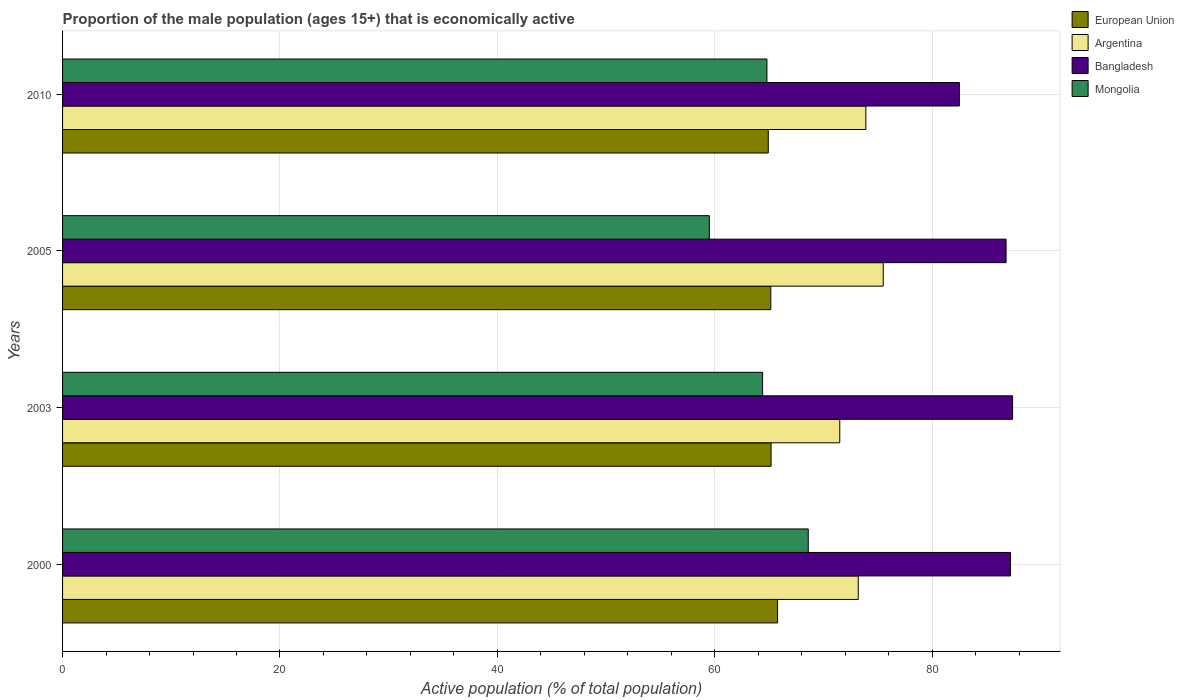How many different coloured bars are there?
Your answer should be very brief. 4. Are the number of bars per tick equal to the number of legend labels?
Provide a succinct answer. Yes. What is the proportion of the male population that is economically active in European Union in 2003?
Make the answer very short. 65.18. Across all years, what is the maximum proportion of the male population that is economically active in Bangladesh?
Provide a short and direct response. 87.4. Across all years, what is the minimum proportion of the male population that is economically active in Bangladesh?
Offer a terse response. 82.5. In which year was the proportion of the male population that is economically active in European Union maximum?
Ensure brevity in your answer.  2000. In which year was the proportion of the male population that is economically active in Mongolia minimum?
Give a very brief answer. 2005. What is the total proportion of the male population that is economically active in Bangladesh in the graph?
Ensure brevity in your answer.  343.9. What is the difference between the proportion of the male population that is economically active in Bangladesh in 2000 and that in 2010?
Offer a terse response. 4.7. What is the difference between the proportion of the male population that is economically active in Mongolia in 2010 and the proportion of the male population that is economically active in European Union in 2003?
Keep it short and to the point. -0.38. What is the average proportion of the male population that is economically active in Bangladesh per year?
Keep it short and to the point. 85.98. In the year 2000, what is the difference between the proportion of the male population that is economically active in European Union and proportion of the male population that is economically active in Argentina?
Ensure brevity in your answer.  -7.42. What is the ratio of the proportion of the male population that is economically active in Mongolia in 2003 to that in 2005?
Give a very brief answer. 1.08. Is the proportion of the male population that is economically active in Argentina in 2000 less than that in 2010?
Your response must be concise. Yes. Is the difference between the proportion of the male population that is economically active in European Union in 2000 and 2005 greater than the difference between the proportion of the male population that is economically active in Argentina in 2000 and 2005?
Keep it short and to the point. Yes. What is the difference between the highest and the second highest proportion of the male population that is economically active in Bangladesh?
Your answer should be very brief. 0.2. What is the difference between the highest and the lowest proportion of the male population that is economically active in Bangladesh?
Keep it short and to the point. 4.9. Is it the case that in every year, the sum of the proportion of the male population that is economically active in Mongolia and proportion of the male population that is economically active in Bangladesh is greater than the sum of proportion of the male population that is economically active in Argentina and proportion of the male population that is economically active in European Union?
Provide a succinct answer. No. What does the 3rd bar from the top in 2005 represents?
Provide a short and direct response. Argentina. What does the 3rd bar from the bottom in 2010 represents?
Offer a very short reply. Bangladesh. What is the difference between two consecutive major ticks on the X-axis?
Keep it short and to the point. 20. Are the values on the major ticks of X-axis written in scientific E-notation?
Your answer should be very brief. No. Does the graph contain any zero values?
Keep it short and to the point. No. How many legend labels are there?
Provide a short and direct response. 4. What is the title of the graph?
Offer a terse response. Proportion of the male population (ages 15+) that is economically active. Does "Cayman Islands" appear as one of the legend labels in the graph?
Give a very brief answer. No. What is the label or title of the X-axis?
Ensure brevity in your answer.  Active population (% of total population). What is the Active population (% of total population) of European Union in 2000?
Provide a succinct answer. 65.78. What is the Active population (% of total population) in Argentina in 2000?
Your response must be concise. 73.2. What is the Active population (% of total population) of Bangladesh in 2000?
Your answer should be compact. 87.2. What is the Active population (% of total population) in Mongolia in 2000?
Your answer should be very brief. 68.6. What is the Active population (% of total population) of European Union in 2003?
Provide a succinct answer. 65.18. What is the Active population (% of total population) of Argentina in 2003?
Give a very brief answer. 71.5. What is the Active population (% of total population) of Bangladesh in 2003?
Provide a short and direct response. 87.4. What is the Active population (% of total population) of Mongolia in 2003?
Keep it short and to the point. 64.4. What is the Active population (% of total population) of European Union in 2005?
Give a very brief answer. 65.15. What is the Active population (% of total population) of Argentina in 2005?
Your response must be concise. 75.5. What is the Active population (% of total population) in Bangladesh in 2005?
Give a very brief answer. 86.8. What is the Active population (% of total population) in Mongolia in 2005?
Offer a terse response. 59.5. What is the Active population (% of total population) in European Union in 2010?
Make the answer very short. 64.92. What is the Active population (% of total population) of Argentina in 2010?
Provide a short and direct response. 73.9. What is the Active population (% of total population) of Bangladesh in 2010?
Provide a short and direct response. 82.5. What is the Active population (% of total population) of Mongolia in 2010?
Give a very brief answer. 64.8. Across all years, what is the maximum Active population (% of total population) of European Union?
Your response must be concise. 65.78. Across all years, what is the maximum Active population (% of total population) of Argentina?
Provide a short and direct response. 75.5. Across all years, what is the maximum Active population (% of total population) in Bangladesh?
Your answer should be very brief. 87.4. Across all years, what is the maximum Active population (% of total population) of Mongolia?
Provide a short and direct response. 68.6. Across all years, what is the minimum Active population (% of total population) of European Union?
Your response must be concise. 64.92. Across all years, what is the minimum Active population (% of total population) of Argentina?
Keep it short and to the point. 71.5. Across all years, what is the minimum Active population (% of total population) in Bangladesh?
Give a very brief answer. 82.5. Across all years, what is the minimum Active population (% of total population) of Mongolia?
Offer a very short reply. 59.5. What is the total Active population (% of total population) in European Union in the graph?
Your answer should be very brief. 261.03. What is the total Active population (% of total population) in Argentina in the graph?
Your response must be concise. 294.1. What is the total Active population (% of total population) in Bangladesh in the graph?
Your answer should be very brief. 343.9. What is the total Active population (% of total population) in Mongolia in the graph?
Make the answer very short. 257.3. What is the difference between the Active population (% of total population) of European Union in 2000 and that in 2003?
Provide a short and direct response. 0.6. What is the difference between the Active population (% of total population) in European Union in 2000 and that in 2005?
Offer a very short reply. 0.62. What is the difference between the Active population (% of total population) of Argentina in 2000 and that in 2005?
Your answer should be very brief. -2.3. What is the difference between the Active population (% of total population) in Mongolia in 2000 and that in 2005?
Your answer should be compact. 9.1. What is the difference between the Active population (% of total population) in European Union in 2000 and that in 2010?
Provide a short and direct response. 0.86. What is the difference between the Active population (% of total population) of Bangladesh in 2000 and that in 2010?
Provide a short and direct response. 4.7. What is the difference between the Active population (% of total population) of Mongolia in 2000 and that in 2010?
Ensure brevity in your answer.  3.8. What is the difference between the Active population (% of total population) in European Union in 2003 and that in 2005?
Your answer should be compact. 0.03. What is the difference between the Active population (% of total population) in Bangladesh in 2003 and that in 2005?
Your answer should be very brief. 0.6. What is the difference between the Active population (% of total population) of Mongolia in 2003 and that in 2005?
Make the answer very short. 4.9. What is the difference between the Active population (% of total population) of European Union in 2003 and that in 2010?
Give a very brief answer. 0.26. What is the difference between the Active population (% of total population) in Mongolia in 2003 and that in 2010?
Your answer should be very brief. -0.4. What is the difference between the Active population (% of total population) of European Union in 2005 and that in 2010?
Give a very brief answer. 0.23. What is the difference between the Active population (% of total population) of Bangladesh in 2005 and that in 2010?
Make the answer very short. 4.3. What is the difference between the Active population (% of total population) in European Union in 2000 and the Active population (% of total population) in Argentina in 2003?
Your answer should be very brief. -5.72. What is the difference between the Active population (% of total population) in European Union in 2000 and the Active population (% of total population) in Bangladesh in 2003?
Your answer should be compact. -21.62. What is the difference between the Active population (% of total population) in European Union in 2000 and the Active population (% of total population) in Mongolia in 2003?
Keep it short and to the point. 1.38. What is the difference between the Active population (% of total population) in Argentina in 2000 and the Active population (% of total population) in Bangladesh in 2003?
Your answer should be compact. -14.2. What is the difference between the Active population (% of total population) in Bangladesh in 2000 and the Active population (% of total population) in Mongolia in 2003?
Offer a very short reply. 22.8. What is the difference between the Active population (% of total population) in European Union in 2000 and the Active population (% of total population) in Argentina in 2005?
Your answer should be compact. -9.72. What is the difference between the Active population (% of total population) of European Union in 2000 and the Active population (% of total population) of Bangladesh in 2005?
Make the answer very short. -21.02. What is the difference between the Active population (% of total population) in European Union in 2000 and the Active population (% of total population) in Mongolia in 2005?
Provide a short and direct response. 6.28. What is the difference between the Active population (% of total population) in Argentina in 2000 and the Active population (% of total population) in Mongolia in 2005?
Keep it short and to the point. 13.7. What is the difference between the Active population (% of total population) of Bangladesh in 2000 and the Active population (% of total population) of Mongolia in 2005?
Keep it short and to the point. 27.7. What is the difference between the Active population (% of total population) in European Union in 2000 and the Active population (% of total population) in Argentina in 2010?
Ensure brevity in your answer.  -8.12. What is the difference between the Active population (% of total population) in European Union in 2000 and the Active population (% of total population) in Bangladesh in 2010?
Ensure brevity in your answer.  -16.72. What is the difference between the Active population (% of total population) of European Union in 2000 and the Active population (% of total population) of Mongolia in 2010?
Provide a succinct answer. 0.98. What is the difference between the Active population (% of total population) in Argentina in 2000 and the Active population (% of total population) in Bangladesh in 2010?
Offer a very short reply. -9.3. What is the difference between the Active population (% of total population) of Argentina in 2000 and the Active population (% of total population) of Mongolia in 2010?
Your answer should be compact. 8.4. What is the difference between the Active population (% of total population) in Bangladesh in 2000 and the Active population (% of total population) in Mongolia in 2010?
Your response must be concise. 22.4. What is the difference between the Active population (% of total population) of European Union in 2003 and the Active population (% of total population) of Argentina in 2005?
Your answer should be very brief. -10.32. What is the difference between the Active population (% of total population) of European Union in 2003 and the Active population (% of total population) of Bangladesh in 2005?
Give a very brief answer. -21.62. What is the difference between the Active population (% of total population) in European Union in 2003 and the Active population (% of total population) in Mongolia in 2005?
Your answer should be compact. 5.68. What is the difference between the Active population (% of total population) of Argentina in 2003 and the Active population (% of total population) of Bangladesh in 2005?
Provide a succinct answer. -15.3. What is the difference between the Active population (% of total population) of Bangladesh in 2003 and the Active population (% of total population) of Mongolia in 2005?
Keep it short and to the point. 27.9. What is the difference between the Active population (% of total population) of European Union in 2003 and the Active population (% of total population) of Argentina in 2010?
Your response must be concise. -8.72. What is the difference between the Active population (% of total population) in European Union in 2003 and the Active population (% of total population) in Bangladesh in 2010?
Your answer should be very brief. -17.32. What is the difference between the Active population (% of total population) in European Union in 2003 and the Active population (% of total population) in Mongolia in 2010?
Offer a very short reply. 0.38. What is the difference between the Active population (% of total population) of Argentina in 2003 and the Active population (% of total population) of Mongolia in 2010?
Your answer should be compact. 6.7. What is the difference between the Active population (% of total population) in Bangladesh in 2003 and the Active population (% of total population) in Mongolia in 2010?
Your answer should be very brief. 22.6. What is the difference between the Active population (% of total population) of European Union in 2005 and the Active population (% of total population) of Argentina in 2010?
Ensure brevity in your answer.  -8.75. What is the difference between the Active population (% of total population) of European Union in 2005 and the Active population (% of total population) of Bangladesh in 2010?
Ensure brevity in your answer.  -17.35. What is the difference between the Active population (% of total population) in European Union in 2005 and the Active population (% of total population) in Mongolia in 2010?
Provide a succinct answer. 0.35. What is the difference between the Active population (% of total population) of Argentina in 2005 and the Active population (% of total population) of Mongolia in 2010?
Keep it short and to the point. 10.7. What is the difference between the Active population (% of total population) of Bangladesh in 2005 and the Active population (% of total population) of Mongolia in 2010?
Ensure brevity in your answer.  22. What is the average Active population (% of total population) of European Union per year?
Make the answer very short. 65.26. What is the average Active population (% of total population) of Argentina per year?
Keep it short and to the point. 73.53. What is the average Active population (% of total population) in Bangladesh per year?
Provide a short and direct response. 85.97. What is the average Active population (% of total population) of Mongolia per year?
Your answer should be compact. 64.33. In the year 2000, what is the difference between the Active population (% of total population) of European Union and Active population (% of total population) of Argentina?
Provide a short and direct response. -7.42. In the year 2000, what is the difference between the Active population (% of total population) in European Union and Active population (% of total population) in Bangladesh?
Offer a terse response. -21.42. In the year 2000, what is the difference between the Active population (% of total population) in European Union and Active population (% of total population) in Mongolia?
Your response must be concise. -2.82. In the year 2000, what is the difference between the Active population (% of total population) of Argentina and Active population (% of total population) of Mongolia?
Give a very brief answer. 4.6. In the year 2003, what is the difference between the Active population (% of total population) of European Union and Active population (% of total population) of Argentina?
Offer a very short reply. -6.32. In the year 2003, what is the difference between the Active population (% of total population) of European Union and Active population (% of total population) of Bangladesh?
Your answer should be very brief. -22.22. In the year 2003, what is the difference between the Active population (% of total population) in European Union and Active population (% of total population) in Mongolia?
Offer a very short reply. 0.78. In the year 2003, what is the difference between the Active population (% of total population) in Argentina and Active population (% of total population) in Bangladesh?
Make the answer very short. -15.9. In the year 2005, what is the difference between the Active population (% of total population) of European Union and Active population (% of total population) of Argentina?
Your answer should be very brief. -10.35. In the year 2005, what is the difference between the Active population (% of total population) in European Union and Active population (% of total population) in Bangladesh?
Give a very brief answer. -21.65. In the year 2005, what is the difference between the Active population (% of total population) of European Union and Active population (% of total population) of Mongolia?
Offer a terse response. 5.65. In the year 2005, what is the difference between the Active population (% of total population) in Argentina and Active population (% of total population) in Mongolia?
Your answer should be compact. 16. In the year 2005, what is the difference between the Active population (% of total population) of Bangladesh and Active population (% of total population) of Mongolia?
Provide a succinct answer. 27.3. In the year 2010, what is the difference between the Active population (% of total population) of European Union and Active population (% of total population) of Argentina?
Your response must be concise. -8.98. In the year 2010, what is the difference between the Active population (% of total population) of European Union and Active population (% of total population) of Bangladesh?
Your answer should be compact. -17.58. In the year 2010, what is the difference between the Active population (% of total population) of European Union and Active population (% of total population) of Mongolia?
Make the answer very short. 0.12. In the year 2010, what is the difference between the Active population (% of total population) of Argentina and Active population (% of total population) of Bangladesh?
Provide a short and direct response. -8.6. In the year 2010, what is the difference between the Active population (% of total population) of Argentina and Active population (% of total population) of Mongolia?
Make the answer very short. 9.1. What is the ratio of the Active population (% of total population) in European Union in 2000 to that in 2003?
Make the answer very short. 1.01. What is the ratio of the Active population (% of total population) in Argentina in 2000 to that in 2003?
Offer a terse response. 1.02. What is the ratio of the Active population (% of total population) in Mongolia in 2000 to that in 2003?
Your answer should be very brief. 1.07. What is the ratio of the Active population (% of total population) of European Union in 2000 to that in 2005?
Make the answer very short. 1.01. What is the ratio of the Active population (% of total population) of Argentina in 2000 to that in 2005?
Your response must be concise. 0.97. What is the ratio of the Active population (% of total population) of Bangladesh in 2000 to that in 2005?
Ensure brevity in your answer.  1. What is the ratio of the Active population (% of total population) of Mongolia in 2000 to that in 2005?
Make the answer very short. 1.15. What is the ratio of the Active population (% of total population) of European Union in 2000 to that in 2010?
Offer a very short reply. 1.01. What is the ratio of the Active population (% of total population) in Argentina in 2000 to that in 2010?
Your response must be concise. 0.99. What is the ratio of the Active population (% of total population) of Bangladesh in 2000 to that in 2010?
Ensure brevity in your answer.  1.06. What is the ratio of the Active population (% of total population) in Mongolia in 2000 to that in 2010?
Your answer should be very brief. 1.06. What is the ratio of the Active population (% of total population) in European Union in 2003 to that in 2005?
Offer a terse response. 1. What is the ratio of the Active population (% of total population) of Argentina in 2003 to that in 2005?
Offer a terse response. 0.95. What is the ratio of the Active population (% of total population) of Bangladesh in 2003 to that in 2005?
Offer a terse response. 1.01. What is the ratio of the Active population (% of total population) in Mongolia in 2003 to that in 2005?
Offer a very short reply. 1.08. What is the ratio of the Active population (% of total population) in European Union in 2003 to that in 2010?
Your response must be concise. 1. What is the ratio of the Active population (% of total population) of Argentina in 2003 to that in 2010?
Offer a terse response. 0.97. What is the ratio of the Active population (% of total population) in Bangladesh in 2003 to that in 2010?
Your response must be concise. 1.06. What is the ratio of the Active population (% of total population) in Mongolia in 2003 to that in 2010?
Keep it short and to the point. 0.99. What is the ratio of the Active population (% of total population) in European Union in 2005 to that in 2010?
Provide a short and direct response. 1. What is the ratio of the Active population (% of total population) in Argentina in 2005 to that in 2010?
Ensure brevity in your answer.  1.02. What is the ratio of the Active population (% of total population) of Bangladesh in 2005 to that in 2010?
Your answer should be very brief. 1.05. What is the ratio of the Active population (% of total population) in Mongolia in 2005 to that in 2010?
Your answer should be very brief. 0.92. What is the difference between the highest and the second highest Active population (% of total population) in European Union?
Your answer should be compact. 0.6. What is the difference between the highest and the second highest Active population (% of total population) of Argentina?
Your answer should be very brief. 1.6. What is the difference between the highest and the lowest Active population (% of total population) of European Union?
Give a very brief answer. 0.86. What is the difference between the highest and the lowest Active population (% of total population) in Argentina?
Your answer should be compact. 4. What is the difference between the highest and the lowest Active population (% of total population) of Bangladesh?
Give a very brief answer. 4.9. 